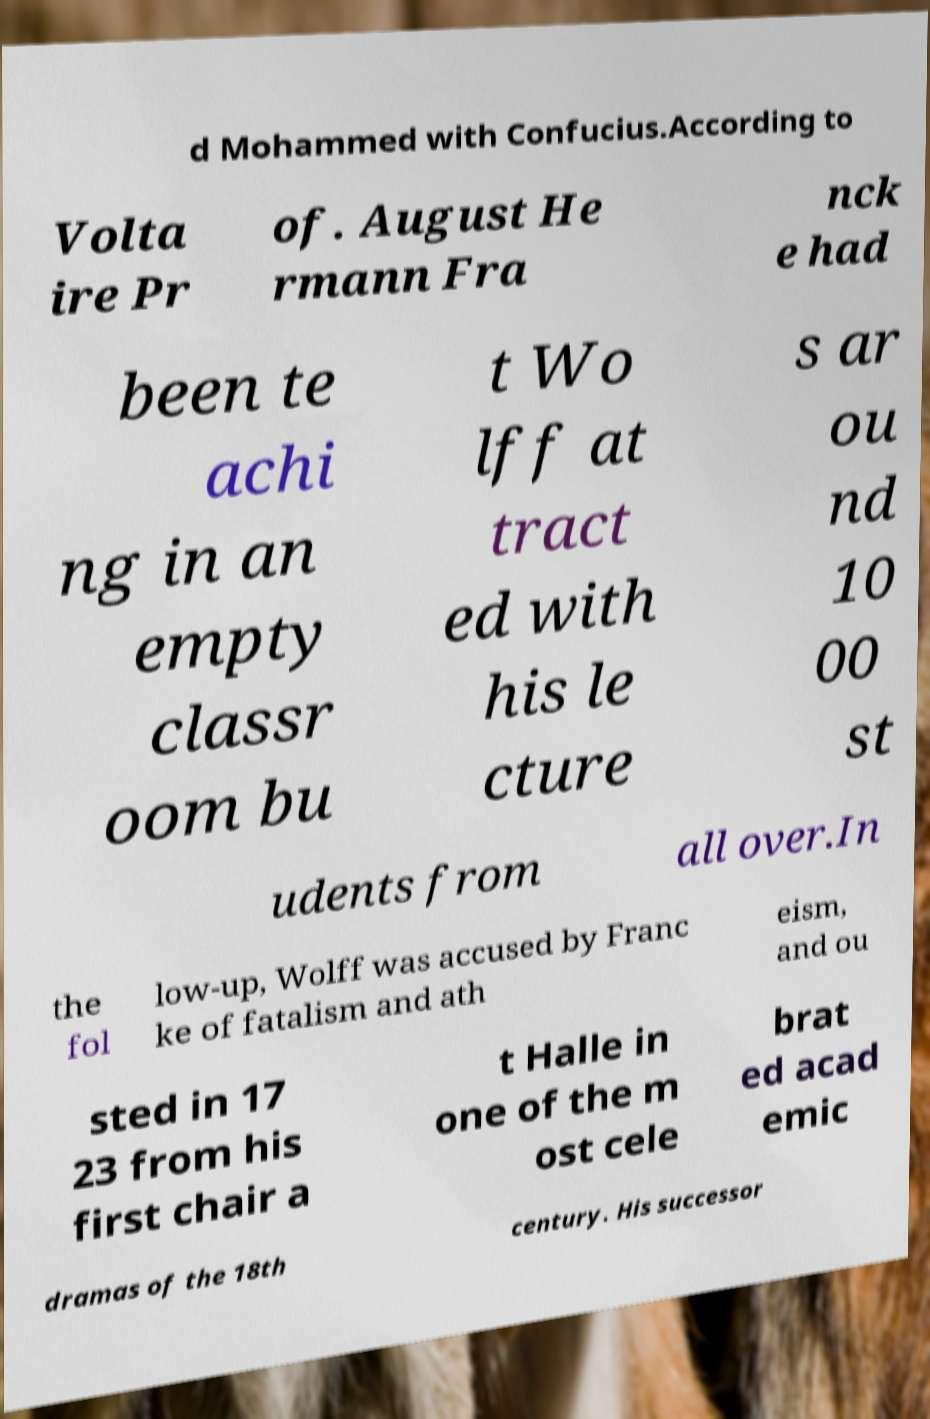I need the written content from this picture converted into text. Can you do that? d Mohammed with Confucius.According to Volta ire Pr of. August He rmann Fra nck e had been te achi ng in an empty classr oom bu t Wo lff at tract ed with his le cture s ar ou nd 10 00 st udents from all over.In the fol low-up, Wolff was accused by Franc ke of fatalism and ath eism, and ou sted in 17 23 from his first chair a t Halle in one of the m ost cele brat ed acad emic dramas of the 18th century. His successor 